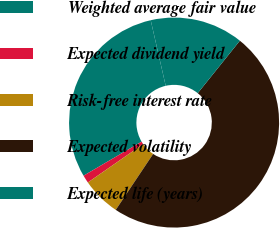Convert chart. <chart><loc_0><loc_0><loc_500><loc_500><pie_chart><fcel>Weighted average fair value<fcel>Expected dividend yield<fcel>Risk-free interest rate<fcel>Expected volatility<fcel>Expected life (years)<nl><fcel>29.87%<fcel>1.22%<fcel>5.96%<fcel>48.61%<fcel>14.35%<nl></chart> 